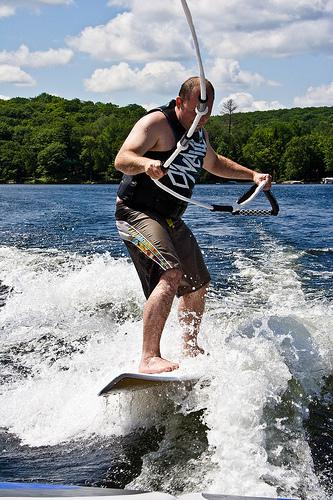Question: why is he holding a rope?
Choices:
A. To climb.
B. To tug.
C. To Balance.
D. To tie.
Answer with the letter. Answer: C Question: what is he holding onto?
Choices:
A. String.
B. Bar.
C. A rope.
D. Pole.
Answer with the letter. Answer: C Question: what is the man doing?
Choices:
A. Standing.
B. Boarding.
C. Skiing.
D. Swimming.
Answer with the letter. Answer: B Question: what color is the water?
Choices:
A. Green.
B. Red.
C. Blue.
D. Orange.
Answer with the letter. Answer: C Question: where is he surfing?
Choices:
A. Beach.
B. On water.
C. Wave machine pool.
D. Ocean.
Answer with the letter. Answer: B 